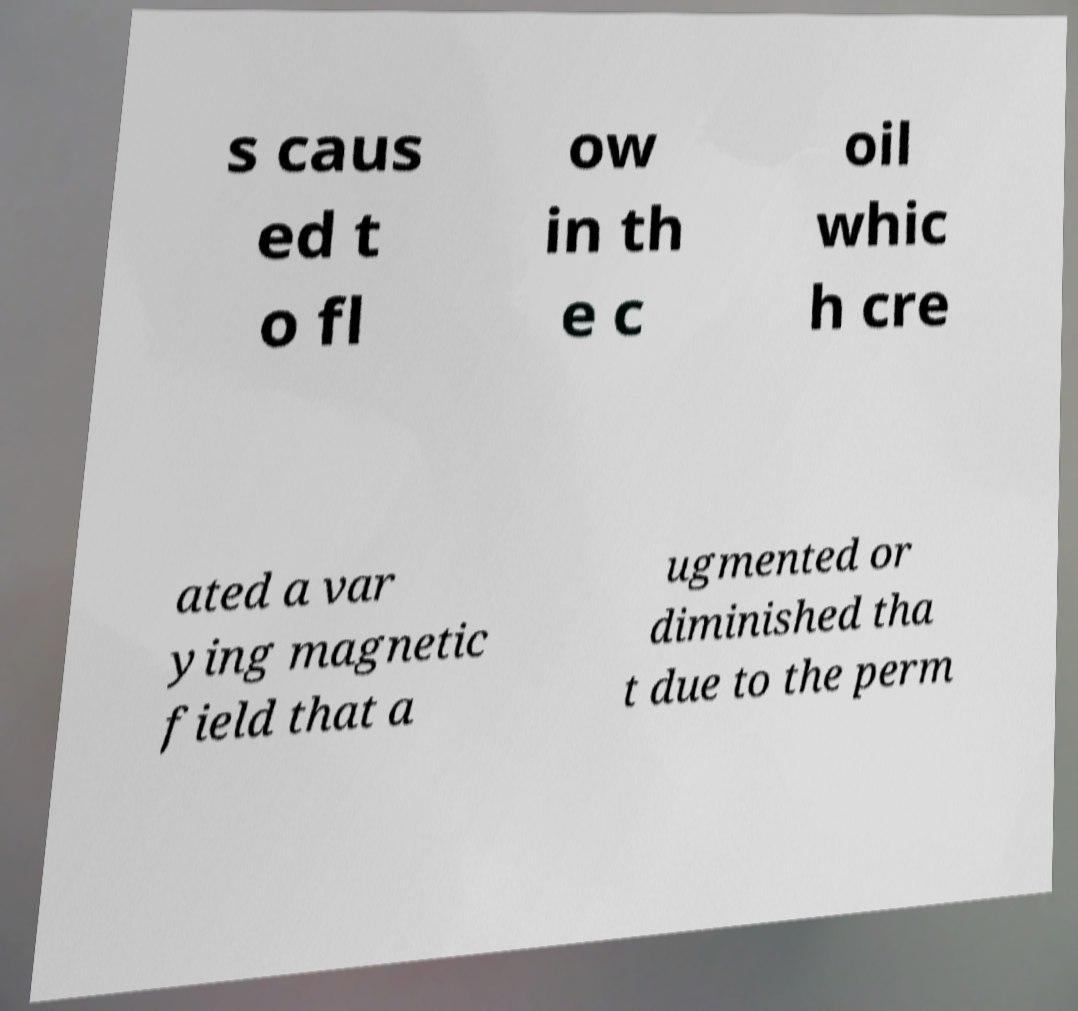Can you read and provide the text displayed in the image?This photo seems to have some interesting text. Can you extract and type it out for me? s caus ed t o fl ow in th e c oil whic h cre ated a var ying magnetic field that a ugmented or diminished tha t due to the perm 